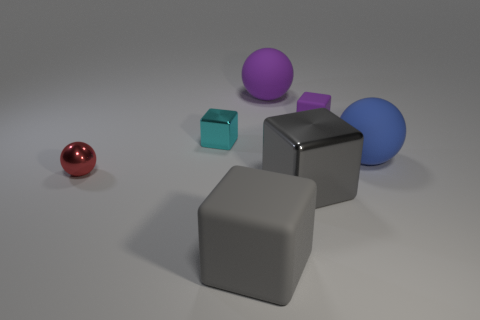How many gray blocks must be subtracted to get 1 gray blocks? 1 Subtract all large purple matte spheres. How many spheres are left? 2 Subtract all purple blocks. How many blocks are left? 3 Add 2 small red metal balls. How many objects exist? 9 Subtract 2 spheres. How many spheres are left? 1 Subtract all purple spheres. Subtract all yellow cylinders. How many spheres are left? 2 Subtract all cubes. How many objects are left? 3 Subtract all purple spheres. How many purple blocks are left? 1 Subtract 0 yellow cylinders. How many objects are left? 7 Subtract all big purple rubber things. Subtract all tiny purple matte cubes. How many objects are left? 5 